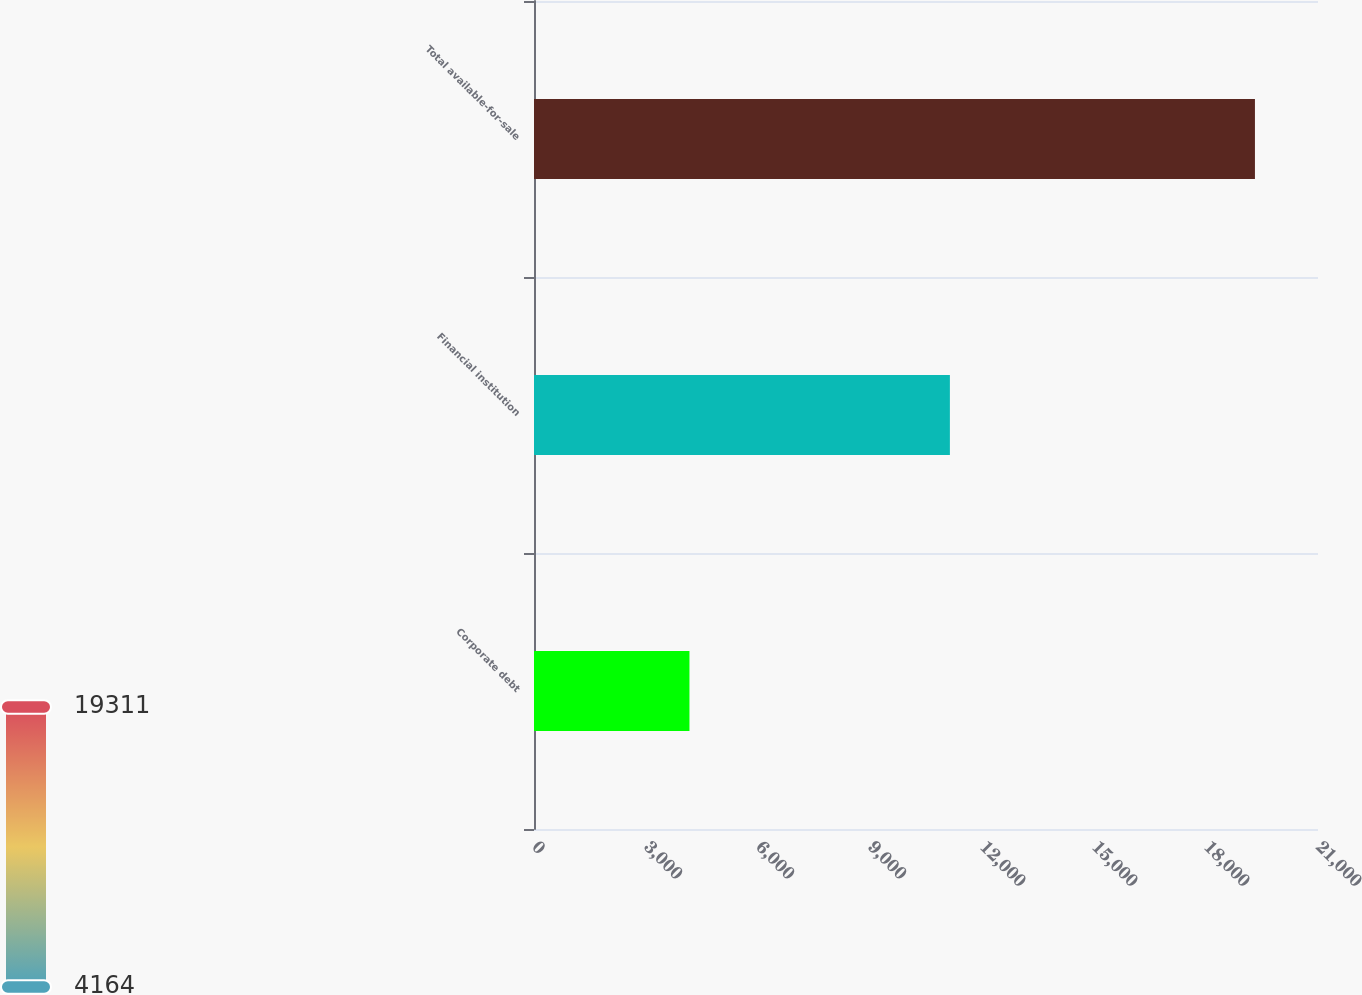Convert chart to OTSL. <chart><loc_0><loc_0><loc_500><loc_500><bar_chart><fcel>Corporate debt<fcel>Financial institution<fcel>Total available-for-sale<nl><fcel>4164<fcel>11140<fcel>19311<nl></chart> 